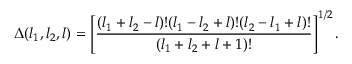<formula> <loc_0><loc_0><loc_500><loc_500>\Delta ( l _ { 1 } , l _ { 2 } , l ) = \left [ { \frac { ( l _ { 1 } + l _ { 2 } - l ) ! ( l _ { 1 } - l _ { 2 } + l ) ! ( l _ { 2 } - l _ { 1 } + l ) ! } { ( l _ { 1 } + l _ { 2 } + l + 1 ) ! } } \right ] ^ { 1 / 2 } .</formula> 